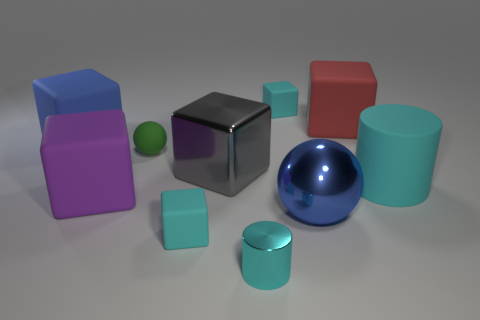Subtract 3 cubes. How many cubes are left? 3 Subtract all red cubes. How many cubes are left? 5 Subtract all gray metal blocks. How many blocks are left? 5 Subtract all brown blocks. Subtract all gray cylinders. How many blocks are left? 6 Subtract all spheres. How many objects are left? 8 Add 10 brown spheres. How many brown spheres exist? 10 Subtract 0 red cylinders. How many objects are left? 10 Subtract all large cyan things. Subtract all large cyan cylinders. How many objects are left? 8 Add 4 blue cubes. How many blue cubes are left? 5 